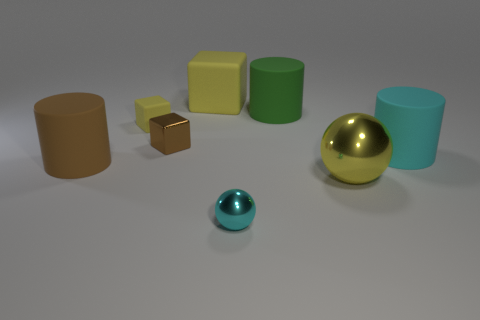Do the big cylinder in front of the big cyan matte cylinder and the small metallic cube have the same color?
Offer a very short reply. Yes. The large object that is the same color as the small shiny cube is what shape?
Provide a succinct answer. Cylinder. There is a block that is the same size as the green rubber object; what color is it?
Ensure brevity in your answer.  Yellow. Are there the same number of large rubber things behind the small yellow matte block and spheres?
Keep it short and to the point. Yes. There is a matte cylinder behind the cylinder that is to the right of the big ball; what is its color?
Provide a succinct answer. Green. How big is the cyan object that is behind the rubber cylinder that is on the left side of the small cyan ball?
Offer a very short reply. Large. There is a metal thing that is the same color as the tiny matte thing; what is its size?
Your answer should be very brief. Large. What number of other things are there of the same size as the green object?
Offer a terse response. 4. There is a metal thing that is behind the cylinder that is left of the matte block that is in front of the green thing; what color is it?
Provide a succinct answer. Brown. What number of other things are there of the same shape as the cyan rubber object?
Offer a very short reply. 2. 